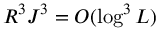<formula> <loc_0><loc_0><loc_500><loc_500>R ^ { 3 } J ^ { 3 } = O ( \log ^ { 3 } L )</formula> 